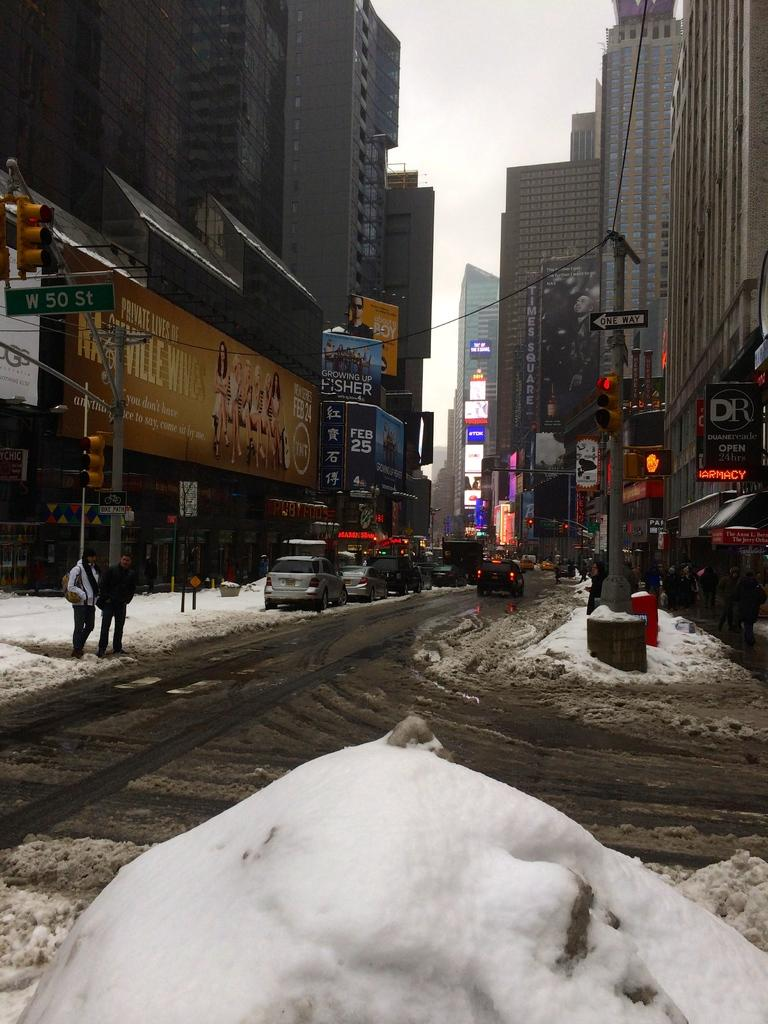What type of natural element is present at the bottom of the image? There is white color snow at the bottom of the image. What type of vehicles can be seen in the image? Cars are present in the image. What type of structures are visible in the image? There are buildings in the image. What type of objects are present in the image that are used for supporting wires or signs? Poles are visible in the image. What type of living organisms can be seen in the image? There are people in the image. What is visible in the background of the image? The sky is visible in the background of the image. What type of lace is being used to decorate the buildings in the image? There is no lace present in the image; it features snow, cars, buildings, poles, people, and a visible sky. What type of reaction can be seen on the faces of the people in the image? There is no indication of facial expressions or reactions on the people in the image, as their faces are not visible. 